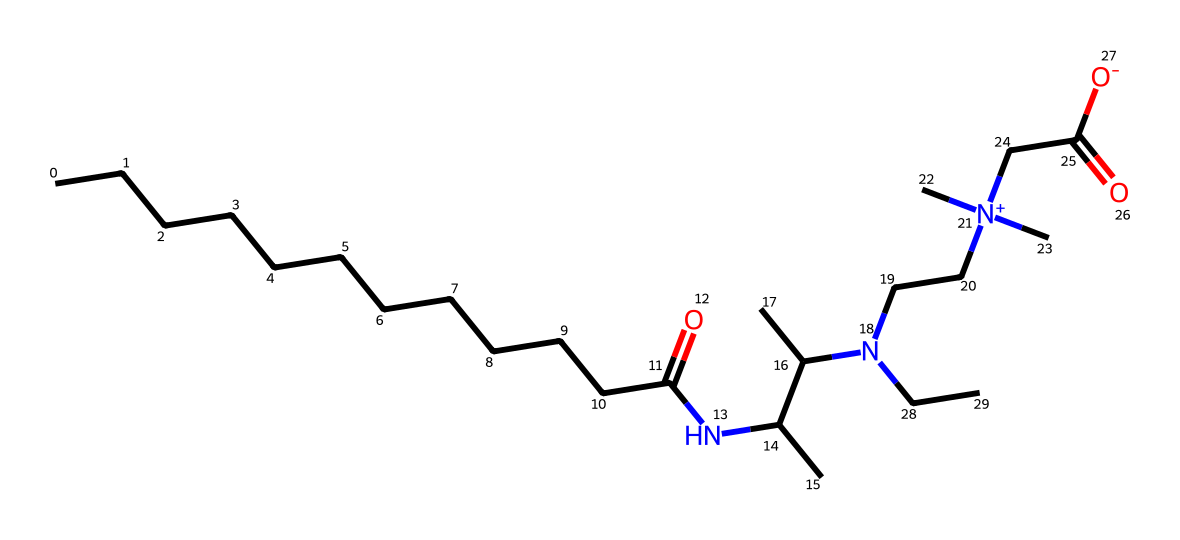What is the molecular formula of cocamidopropyl betaine? To determine the molecular formula, count the number of each type of atom in the SMILES representation. This includes counting carbon (C), hydrogen (H), oxygen (O), and nitrogen (N) atoms present in the structure. The total count leads to the molecular formula C21H42N2O2.
Answer: C21H42N2O2 How many nitrogen atoms are found in this compound? The SMILES representation contains the letter 'N', which indicates the presence of nitrogen atoms. Counting them, we see there are 2 nitrogen atoms in the structure.
Answer: 2 What type of surfactant is cocamidopropyl betaine classified as? The functional groups, particularly the quaternary ammonium group (noted by [N+]), and the presence of both hydrophilic and hydrophobic regions indicate it is an amphoteric surfactant.
Answer: amphoteric Which part of the molecule contributes to its eco-friendly properties? The long carbon chain and the presence of a carboxylate group ([-O] at the end of the molecule) suggest the bio-degradability and reduced toxicity of the compound, contributing to its eco-friendly nature.
Answer: carboxylate group How many carbon atoms are present in cocamidopropyl betaine? By examining the SMILES representation, count the 'C's. The total number of carbon atoms in the molecule is 21.
Answer: 21 What role do the alkyl chains play in the detergency of cocamidopropyl betaine? The long alkyl chains enhance the hydrophobic interactions with grease and oil, assisting in emulsification and cleaning efficiency of the surfactant in detergent formulations.
Answer: emulsification 